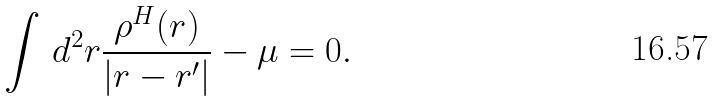<formula> <loc_0><loc_0><loc_500><loc_500>\int \, d ^ { 2 } { r } \frac { \rho ^ { H } { ( { r } ) } } { | { r } - { r ^ { \prime } } | } - \mu = 0 .</formula> 